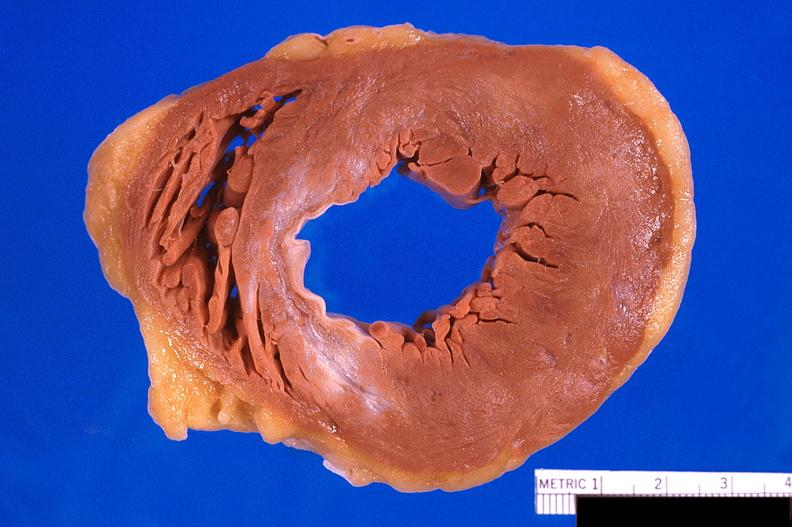does retroperitoneum show heart, old myocardial infarction with fibrosis?
Answer the question using a single word or phrase. No 